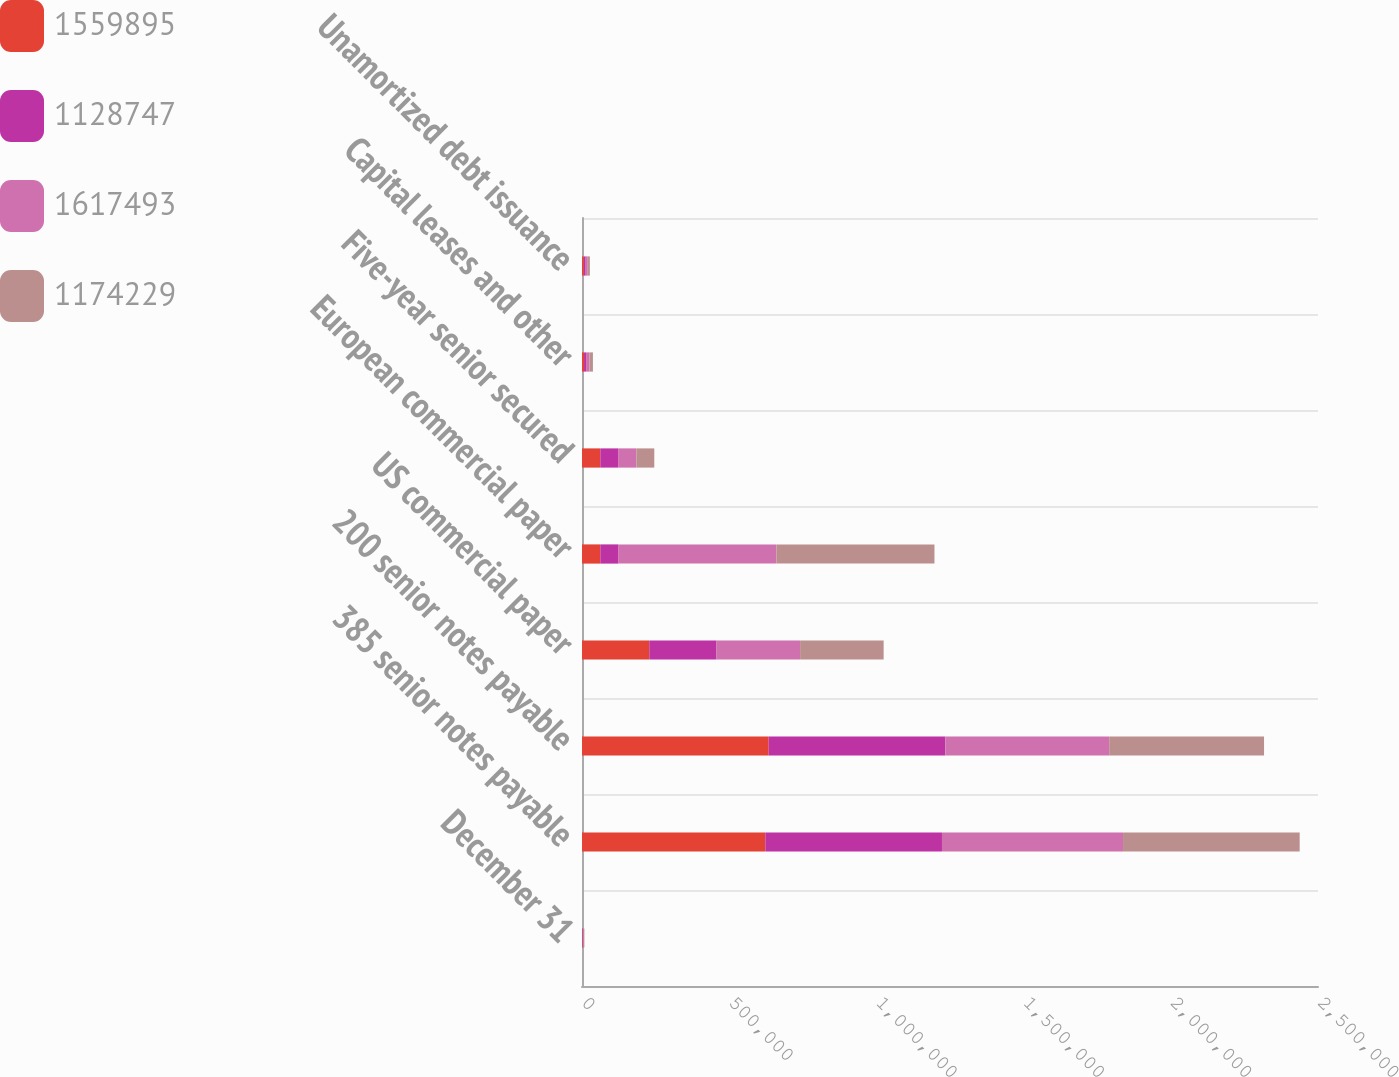Convert chart to OTSL. <chart><loc_0><loc_0><loc_500><loc_500><stacked_bar_chart><ecel><fcel>December 31<fcel>385 senior notes payable<fcel>200 senior notes payable<fcel>US commercial paper<fcel>European commercial paper<fcel>Five-year senior secured<fcel>Capital leases and other<fcel>Unamortized debt issuance<nl><fcel>1.5599e+06<fcel>2017<fcel>622752<fcel>634193<fcel>228500<fcel>62104<fcel>62104<fcel>6934<fcel>6260<nl><fcel>1.12875e+06<fcel>2017<fcel>600000<fcel>600096<fcel>228500<fcel>62104<fcel>62104<fcel>6934<fcel>6260<nl><fcel>1.61749e+06<fcel>2016<fcel>615006<fcel>556460<fcel>283800<fcel>536503<fcel>60672<fcel>11643<fcel>7117<nl><fcel>1.17423e+06<fcel>2016<fcel>600000<fcel>525984<fcel>283800<fcel>536503<fcel>60672<fcel>11643<fcel>7117<nl></chart> 